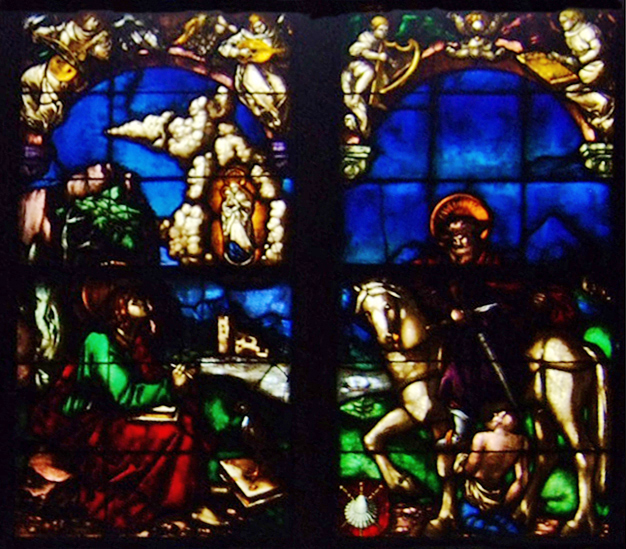What is this photo about? The image details an intricate stained glass window likely from a church or cathedral, known for its Gothic architectural elements. The window is composed of two primary panels, each topped with a semicircular arch and separated by a mullion. Each panel features a scene with a male and a female figure, both dressed in historical, vibrantly colored robes, engaged in a peaceful interaction. The men are depicted kneeling, which alongside the women holding books and lilies, suggests themes of learning, purity, and devotion. The use of rich colors—red, green, blue, and gold—enhances the visual impact and symbolism of the piece, perhaps reflecting divine qualities. Moreover, the panels are framed by ornate tracery, contributing to the window's majestic and sacred ambiance, typical of Gothic religious art. 